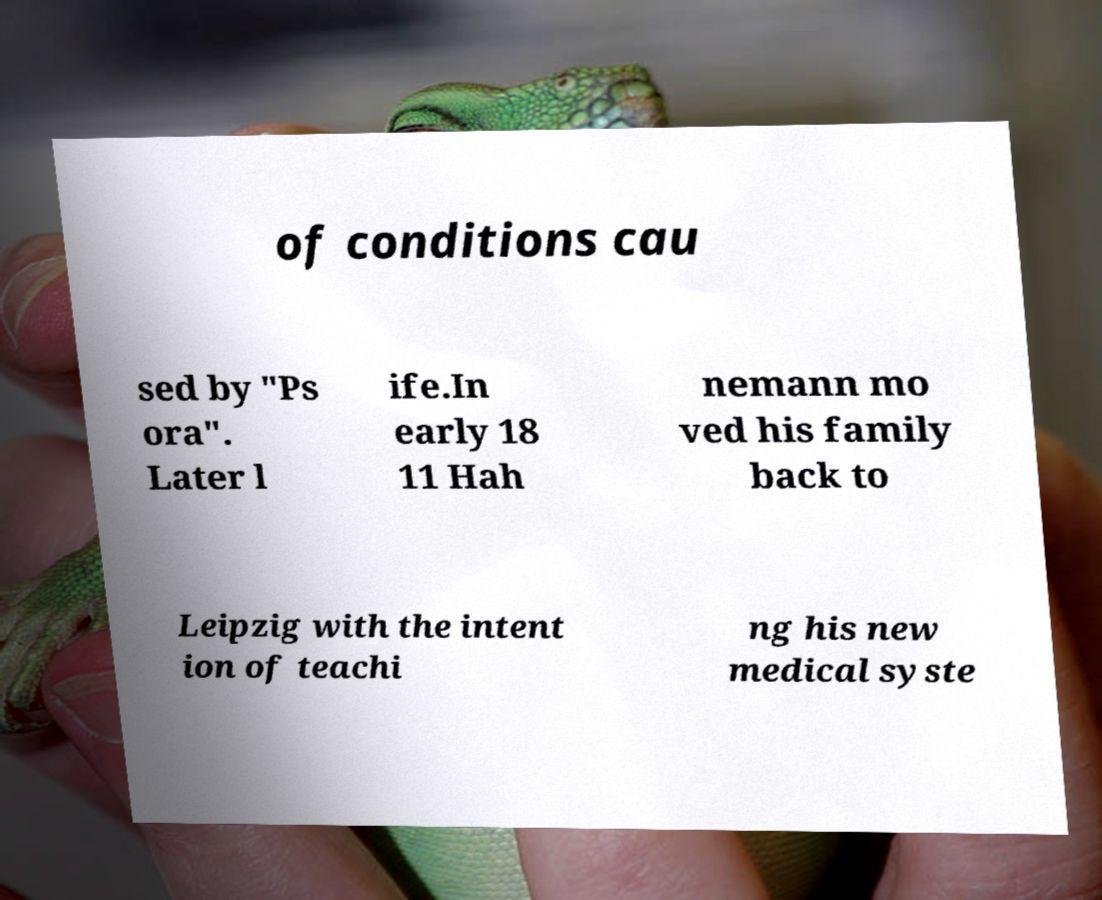I need the written content from this picture converted into text. Can you do that? of conditions cau sed by "Ps ora". Later l ife.In early 18 11 Hah nemann mo ved his family back to Leipzig with the intent ion of teachi ng his new medical syste 